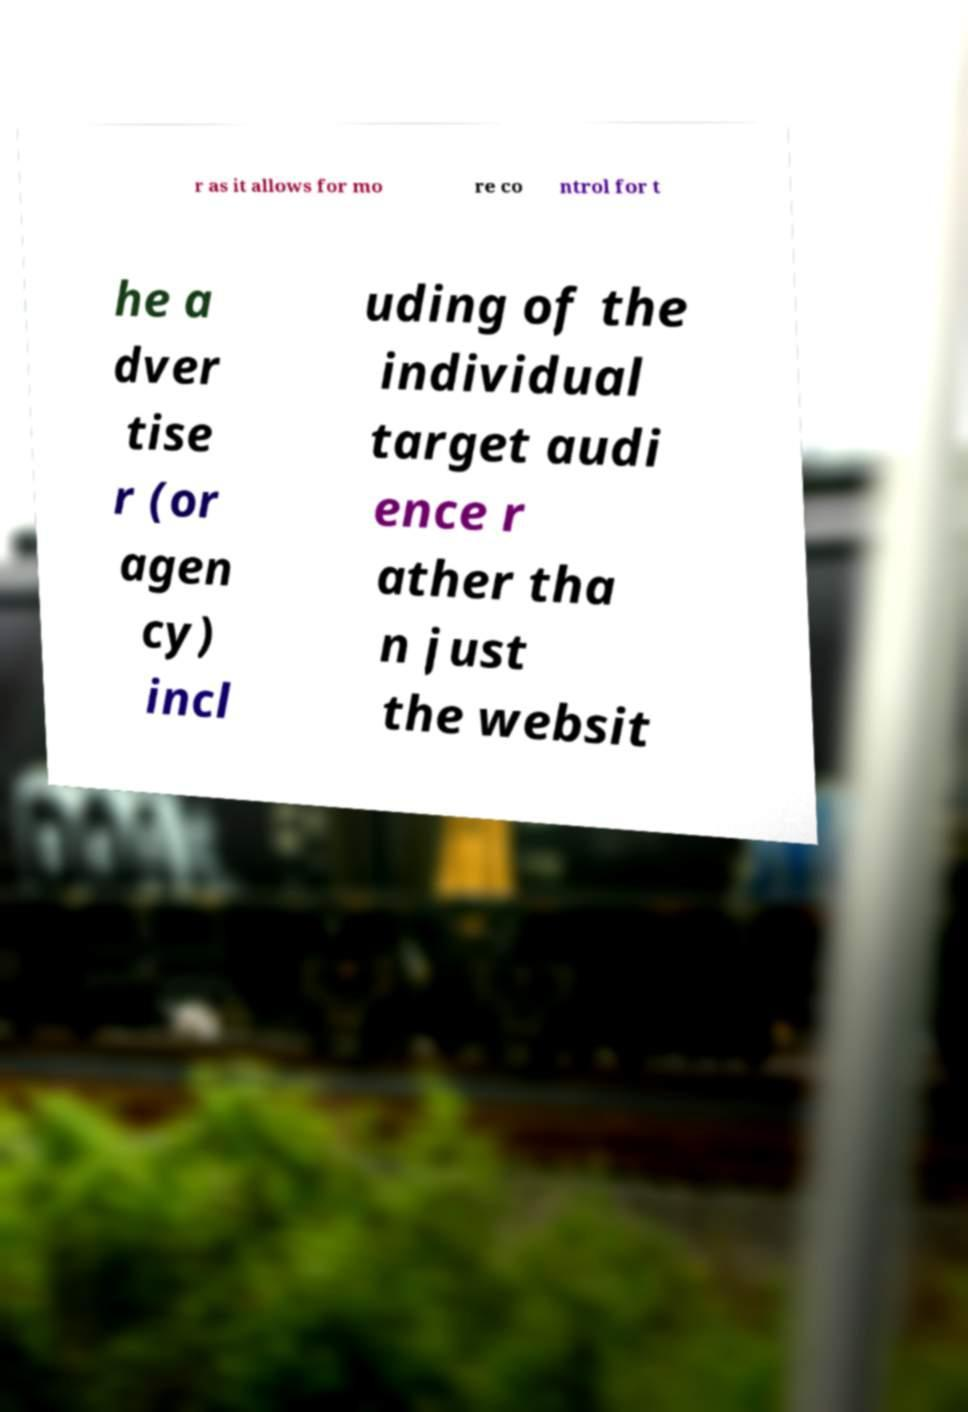Could you extract and type out the text from this image? r as it allows for mo re co ntrol for t he a dver tise r (or agen cy) incl uding of the individual target audi ence r ather tha n just the websit 